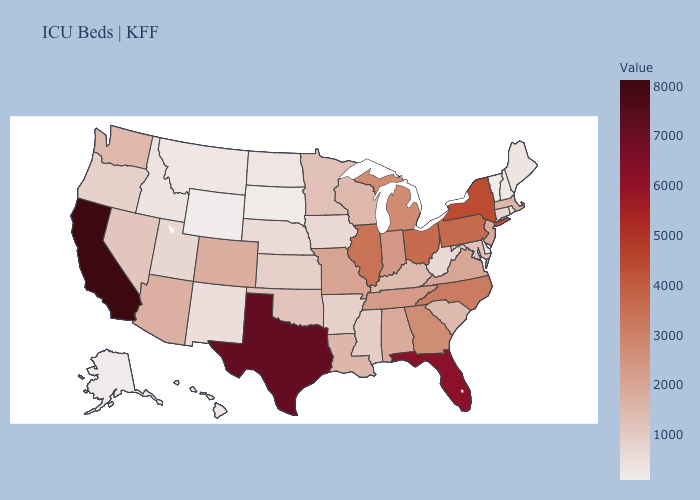Does Missouri have a higher value than Nevada?
Short answer required. Yes. Does California have the highest value in the USA?
Quick response, please. Yes. Among the states that border Missouri , which have the highest value?
Keep it brief. Illinois. Which states hav the highest value in the Northeast?
Answer briefly. New York. Does Massachusetts have the highest value in the Northeast?
Concise answer only. No. Among the states that border Texas , does New Mexico have the lowest value?
Answer briefly. Yes. 